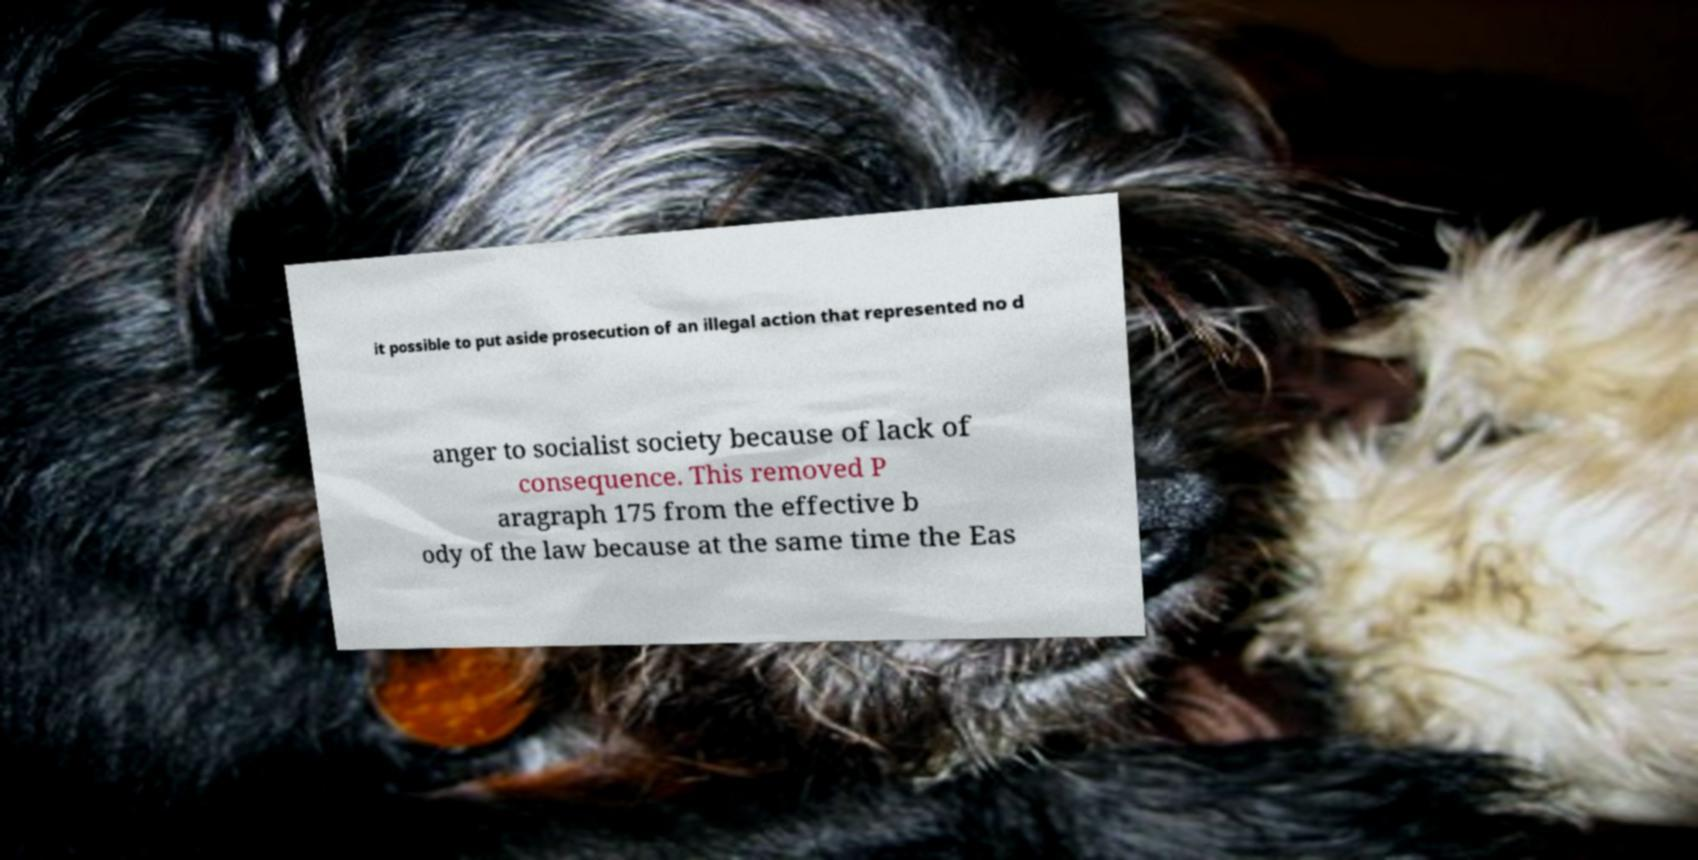Please read and relay the text visible in this image. What does it say? it possible to put aside prosecution of an illegal action that represented no d anger to socialist society because of lack of consequence. This removed P aragraph 175 from the effective b ody of the law because at the same time the Eas 